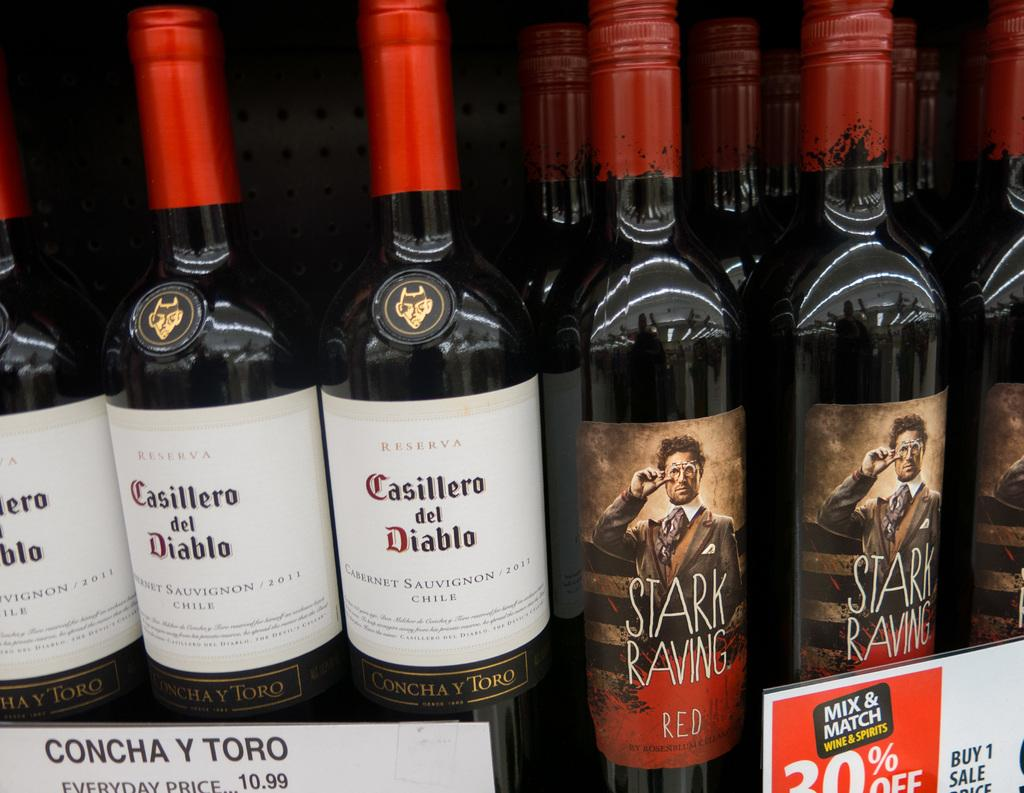<image>
Create a compact narrative representing the image presented. Several bottles of "Casillero del Diablo" and "STARK RAVIN RED" wines are on a shelf.. 